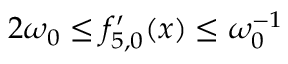Convert formula to latex. <formula><loc_0><loc_0><loc_500><loc_500>2 \omega _ { 0 } \leq { f } _ { 5 , 0 } ^ { \prime } ( x ) \leq \omega _ { 0 } ^ { - 1 }</formula> 